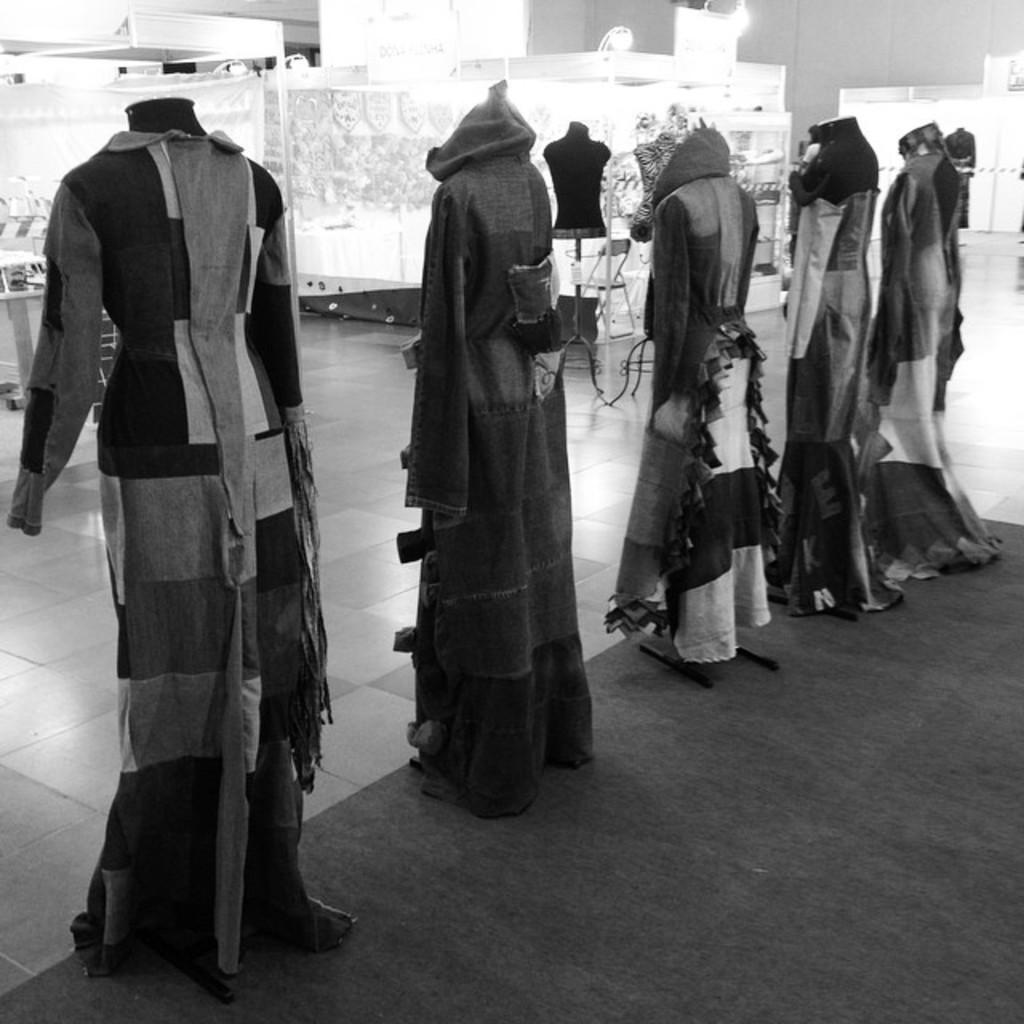What is the color scheme of the image? The image is in black and white. What can be seen in the image? There are mannequins in the image. How are the mannequins dressed? The mannequins are dressed. What is on the floor in the image? There is a carpet on the floor in the image. What is located behind the mannequins? There are stalls behind the mannequins. Can you tell me how many trays are being carried by the mannequins in the image? There are no trays being carried by the mannequins in the image, as they are not holding any objects. Is there a faucet visible in the image? There is no faucet present in the image. 